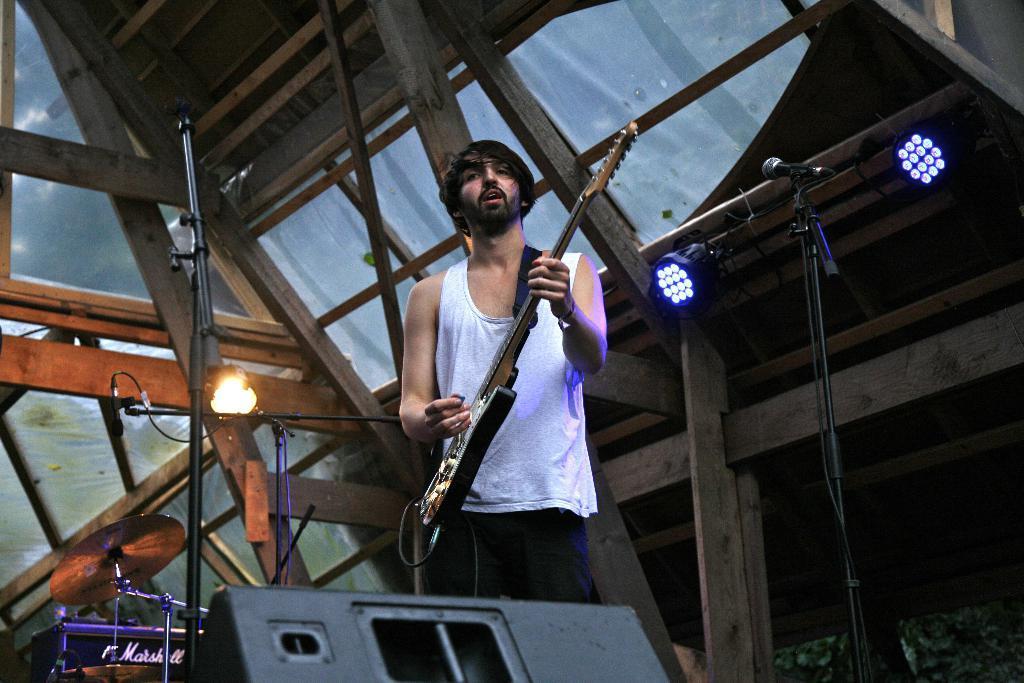Can you describe this image briefly? In this picture we can see a man holding a guitar with his hand and standing and in front of him we can see mics and in the background we can see a roof. 